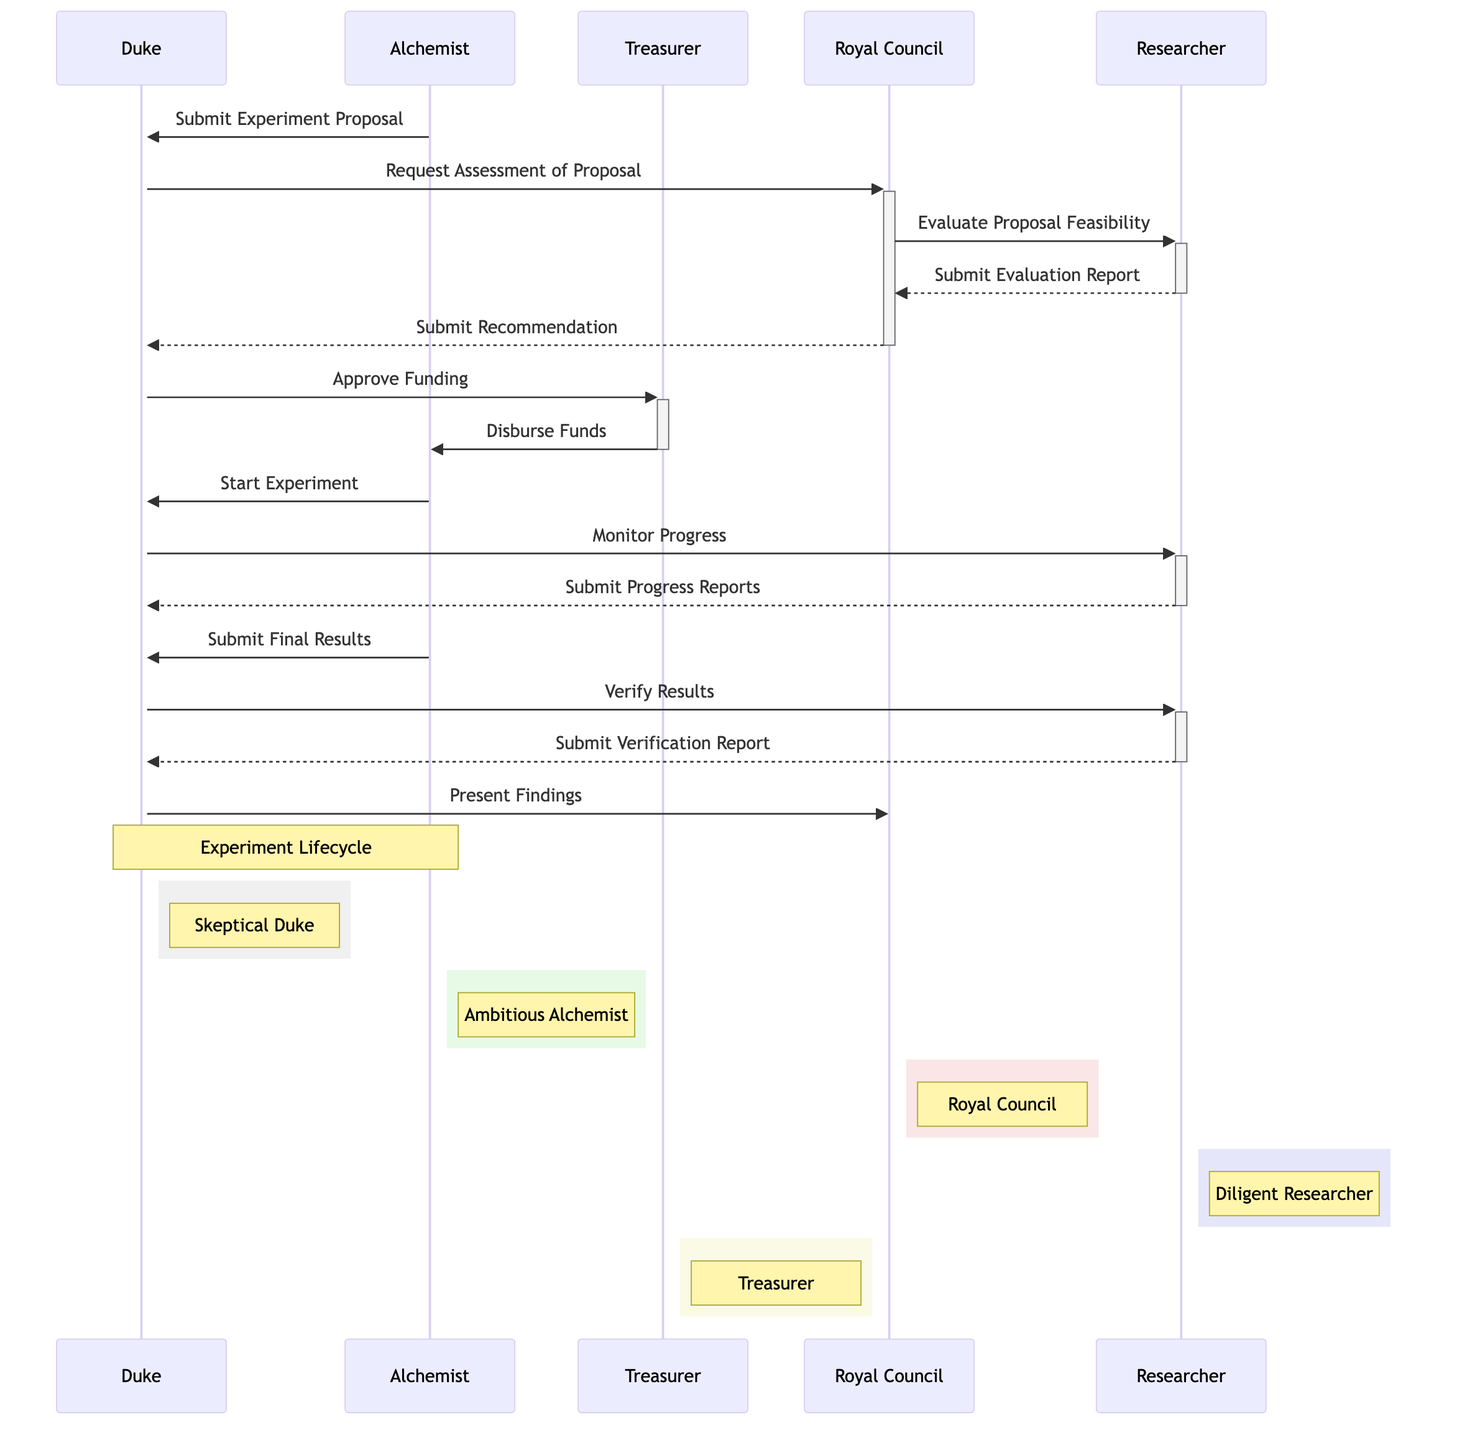What is the first action in this sequence? The first action is initiated by the Alchemist who submits the experiment proposal to the Duke.
Answer: Submit Experiment Proposal Who evaluates the proposal's feasibility? The Royal Council directs the Researcher to evaluate the proposal's feasibility.
Answer: Researcher How many participants are involved in this sequence? The diagram lists five distinct participants: Duke, Alchemist, Treasurer, Royal Council, and Researcher.
Answer: Five What message does the Duke send to the Treasurer? The Duke sends a message to the Treasurer to approve the funding for the experiment.
Answer: Approve Funding What is the last action taken in the sequence? The last action involves the Duke presenting the findings to the Royal Council.
Answer: Present Findings Which participant submits the final results? The Alchemist is responsible for submitting the final results of the experiment.
Answer: Alchemist What report does the Researcher submit after the Duke requests verification? After the Duke requests verification, the Researcher submits a verification report.
Answer: Submit Verification Report Why does the Duke monitor the progress of the experiment? The Duke monitors the experiment's progress to ensure that it aligns with the scope of the approved funding and the proposal.
Answer: To ensure alignment What is the role of the Treasurer in this sequence? The Treasurer's role involves managing the finances, specifically approving funding and disbursing funds to the Alchemist.
Answer: Managing finances 